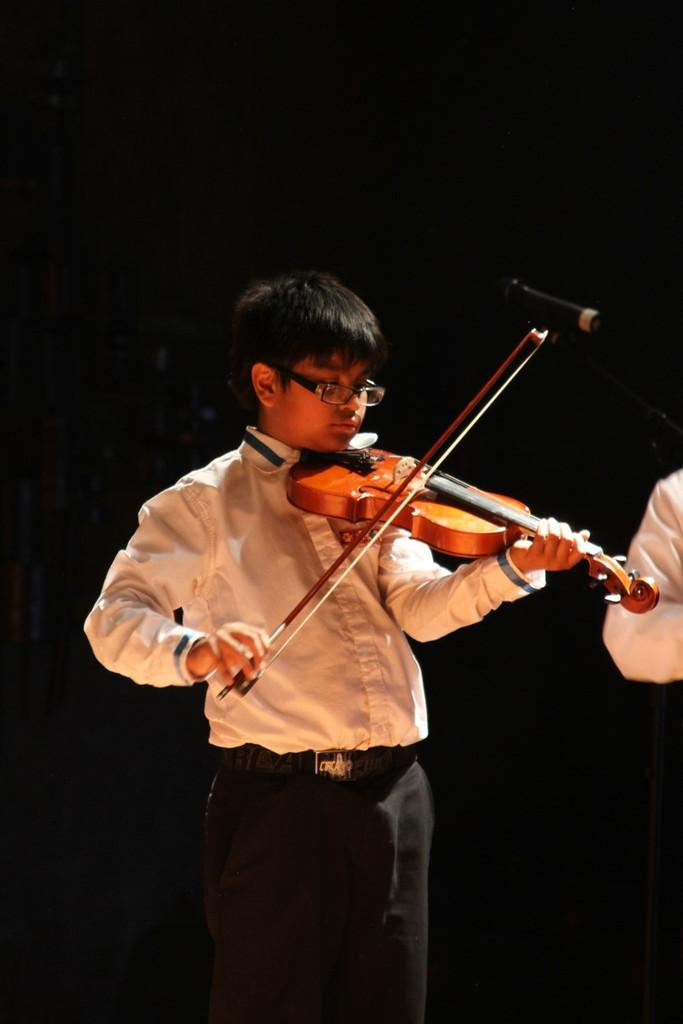Who is the main subject in the image? There is a boy in the image. What is the boy doing in the image? The boy is standing and playing a violin. What is the boy wearing in the image? The boy is wearing a white shirt. What type of fish can be seen swimming near the ship in the image? There is no ship or fish present in the image; it features a boy playing a violin. 